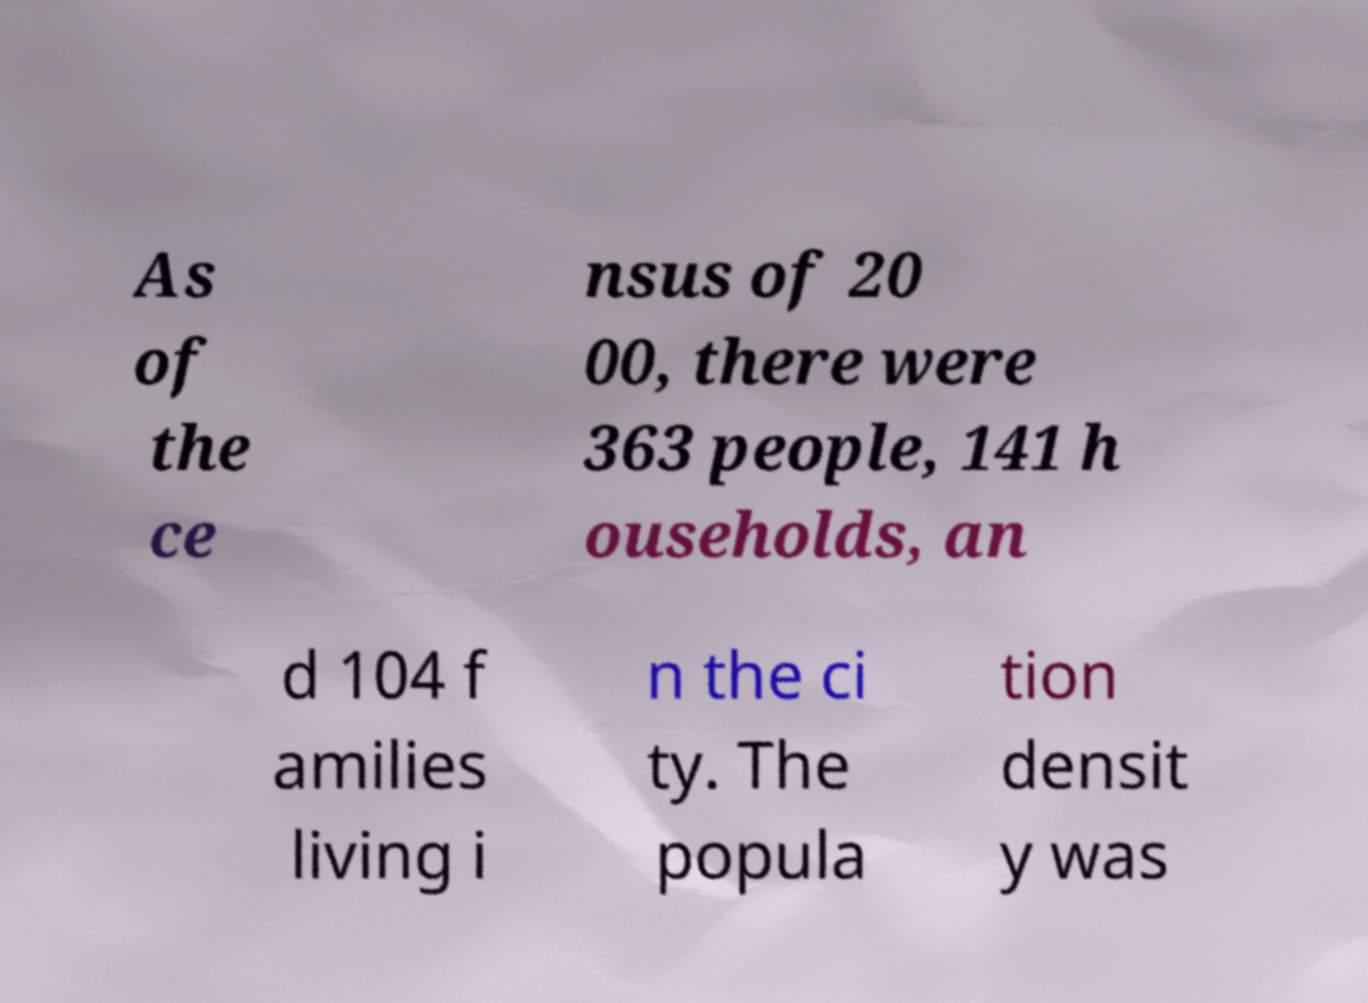There's text embedded in this image that I need extracted. Can you transcribe it verbatim? As of the ce nsus of 20 00, there were 363 people, 141 h ouseholds, an d 104 f amilies living i n the ci ty. The popula tion densit y was 